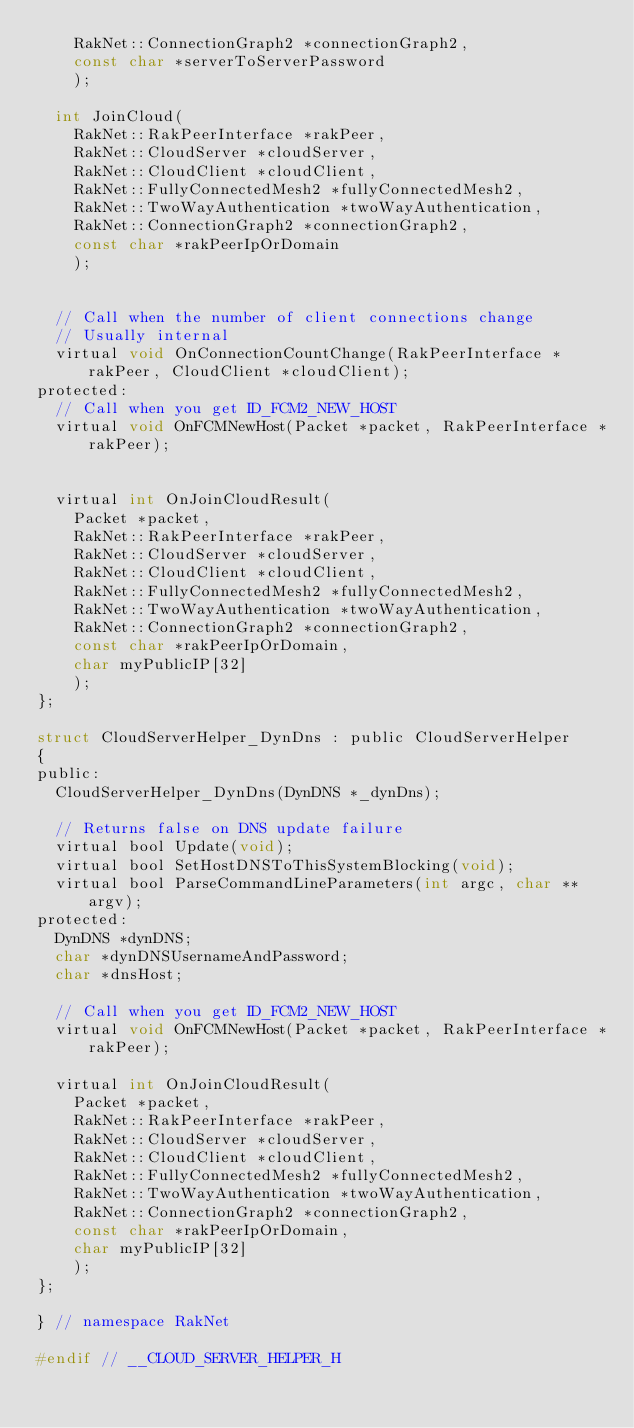<code> <loc_0><loc_0><loc_500><loc_500><_C_>		RakNet::ConnectionGraph2 *connectionGraph2,
		const char *serverToServerPassword
		);

	int JoinCloud(
		RakNet::RakPeerInterface *rakPeer,
		RakNet::CloudServer *cloudServer,
		RakNet::CloudClient *cloudClient,
		RakNet::FullyConnectedMesh2 *fullyConnectedMesh2,
		RakNet::TwoWayAuthentication *twoWayAuthentication,
		RakNet::ConnectionGraph2 *connectionGraph2,
		const char *rakPeerIpOrDomain
		);


	// Call when the number of client connections change
	// Usually internal
	virtual void OnConnectionCountChange(RakPeerInterface *rakPeer, CloudClient *cloudClient);
protected:
	// Call when you get ID_FCM2_NEW_HOST
	virtual void OnFCMNewHost(Packet *packet, RakPeerInterface *rakPeer);


	virtual int OnJoinCloudResult(
		Packet *packet,
		RakNet::RakPeerInterface *rakPeer,
		RakNet::CloudServer *cloudServer,
		RakNet::CloudClient *cloudClient,
		RakNet::FullyConnectedMesh2 *fullyConnectedMesh2,
		RakNet::TwoWayAuthentication *twoWayAuthentication,
		RakNet::ConnectionGraph2 *connectionGraph2,
		const char *rakPeerIpOrDomain,
		char myPublicIP[32]
		);
};

struct CloudServerHelper_DynDns : public CloudServerHelper
{
public:
	CloudServerHelper_DynDns(DynDNS *_dynDns);

	// Returns false on DNS update failure
	virtual bool Update(void);
	virtual bool SetHostDNSToThisSystemBlocking(void);
	virtual bool ParseCommandLineParameters(int argc, char **argv);
protected:
	DynDNS *dynDNS;
	char *dynDNSUsernameAndPassword;
	char *dnsHost;

	// Call when you get ID_FCM2_NEW_HOST
	virtual void OnFCMNewHost(Packet *packet, RakPeerInterface *rakPeer);

	virtual int OnJoinCloudResult(
		Packet *packet,
		RakNet::RakPeerInterface *rakPeer,
		RakNet::CloudServer *cloudServer,
		RakNet::CloudClient *cloudClient,
		RakNet::FullyConnectedMesh2 *fullyConnectedMesh2,
		RakNet::TwoWayAuthentication *twoWayAuthentication,
		RakNet::ConnectionGraph2 *connectionGraph2,
		const char *rakPeerIpOrDomain,
		char myPublicIP[32]
		);
};

} // namespace RakNet

#endif // __CLOUD_SERVER_HELPER_H
</code> 